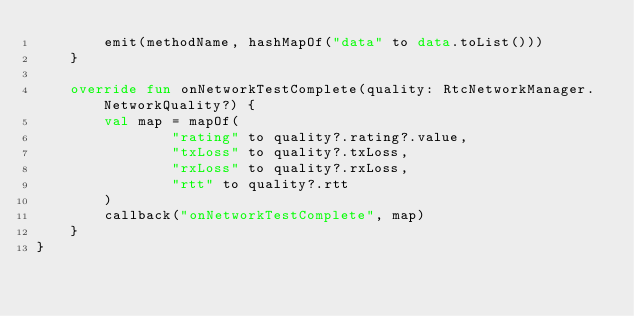Convert code to text. <code><loc_0><loc_0><loc_500><loc_500><_Kotlin_>        emit(methodName, hashMapOf("data" to data.toList()))
    }

    override fun onNetworkTestComplete(quality: RtcNetworkManager.NetworkQuality?) {
        val map = mapOf(
                "rating" to quality?.rating?.value,
                "txLoss" to quality?.txLoss,
                "rxLoss" to quality?.rxLoss,
                "rtt" to quality?.rtt
        )
        callback("onNetworkTestComplete", map)
    }
}</code> 